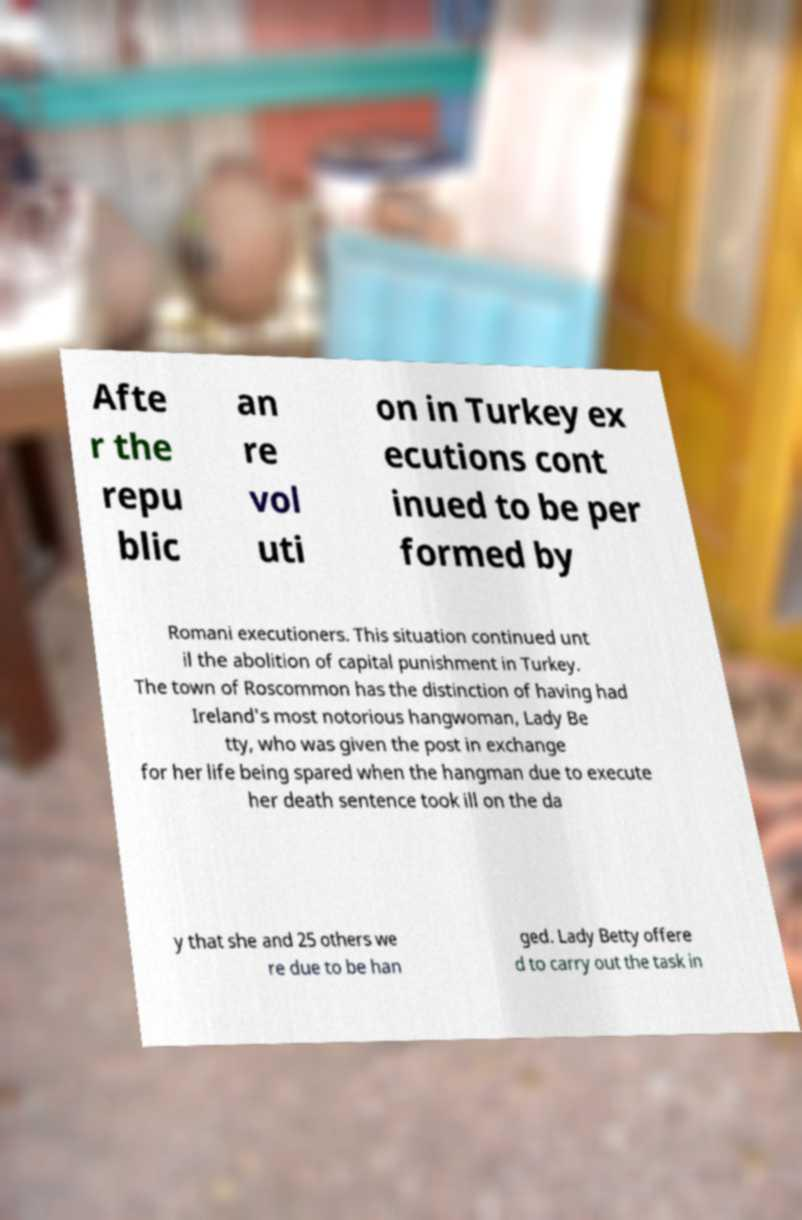Please read and relay the text visible in this image. What does it say? Afte r the repu blic an re vol uti on in Turkey ex ecutions cont inued to be per formed by Romani executioners. This situation continued unt il the abolition of capital punishment in Turkey. The town of Roscommon has the distinction of having had Ireland's most notorious hangwoman, Lady Be tty, who was given the post in exchange for her life being spared when the hangman due to execute her death sentence took ill on the da y that she and 25 others we re due to be han ged. Lady Betty offere d to carry out the task in 